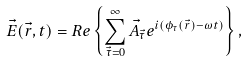Convert formula to latex. <formula><loc_0><loc_0><loc_500><loc_500>\vec { E } ( \vec { r } , t ) = R e \left \{ \sum _ { \vec { \tau } = 0 } ^ { \infty } \vec { A } _ { \vec { \tau } } e ^ { i ( \phi _ { \tau } ( \vec { r } ) - \omega t ) } \right \} ,</formula> 